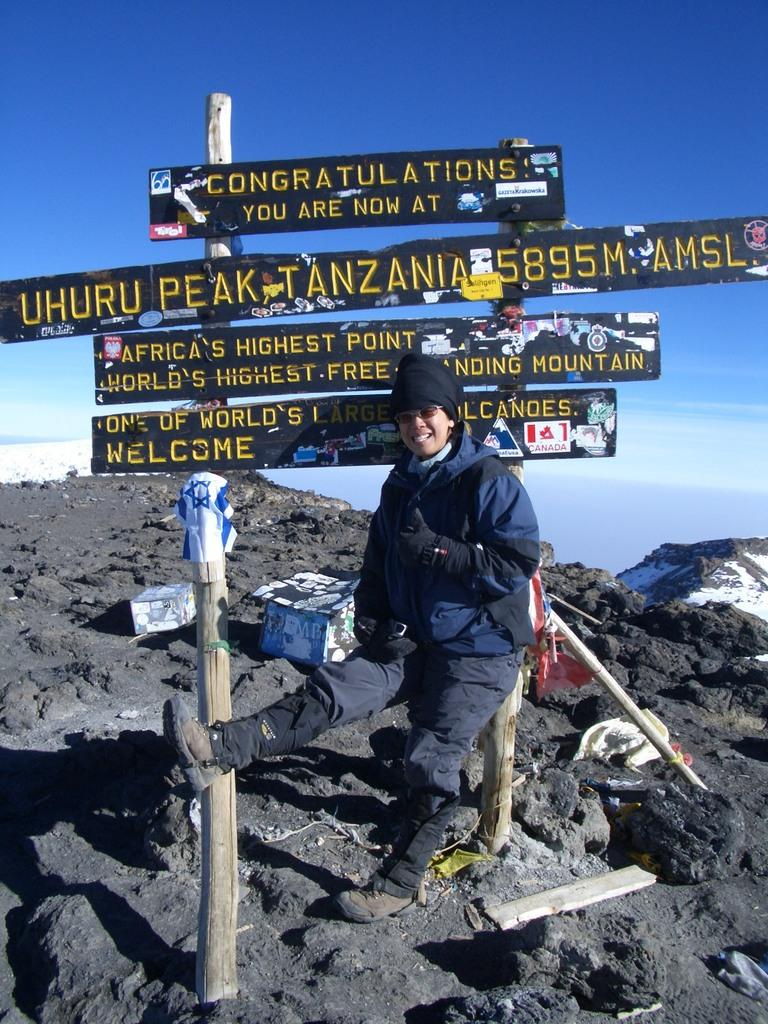What is present in the image that provides information or direction? There is a sign board in the image. Can you describe the person in the image? There is a person wearing a blue jacket in the image. What type of natural landscape can be seen in the image? Hills are visible in the image. What is visible above the hills in the image? The sky is visible in the image. Can you describe the air quality in the image? There is no information provided about the air quality in the image. Is the person in the image being bitten by an animal? There is no indication of an animal or a bite in the image. 